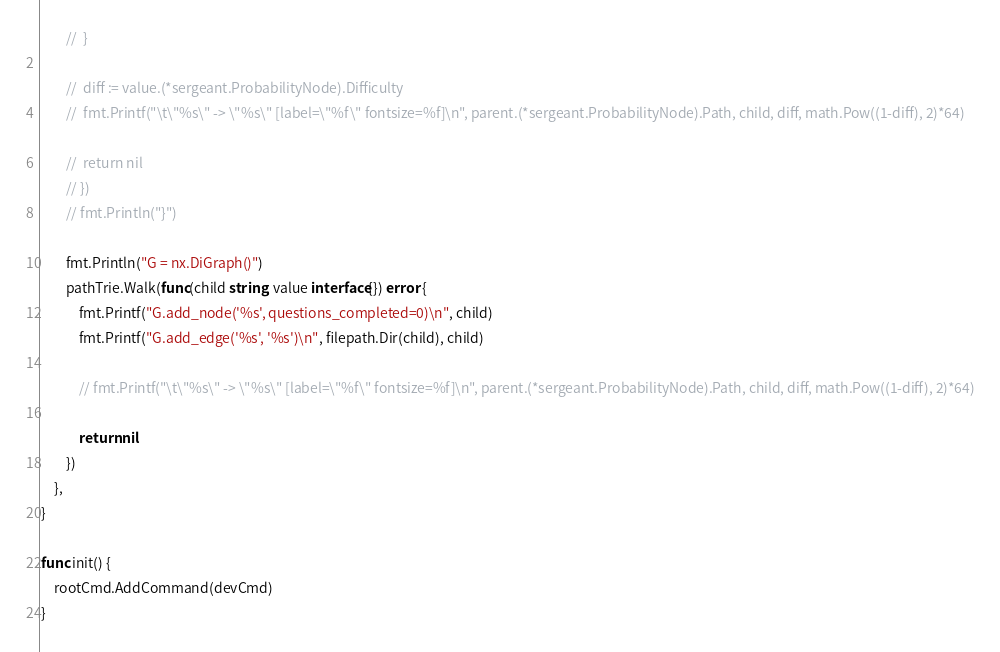Convert code to text. <code><loc_0><loc_0><loc_500><loc_500><_Go_>		// 	}

		// 	diff := value.(*sergeant.ProbabilityNode).Difficulty
		// 	fmt.Printf("\t\"%s\" -> \"%s\" [label=\"%f\" fontsize=%f]\n", parent.(*sergeant.ProbabilityNode).Path, child, diff, math.Pow((1-diff), 2)*64)

		// 	return nil
		// })
		// fmt.Println("}")

		fmt.Println("G = nx.DiGraph()")
		pathTrie.Walk(func(child string, value interface{}) error {
			fmt.Printf("G.add_node('%s', questions_completed=0)\n", child)
			fmt.Printf("G.add_edge('%s', '%s')\n", filepath.Dir(child), child)

			// fmt.Printf("\t\"%s\" -> \"%s\" [label=\"%f\" fontsize=%f]\n", parent.(*sergeant.ProbabilityNode).Path, child, diff, math.Pow((1-diff), 2)*64)

			return nil
		})
	},
}

func init() {
	rootCmd.AddCommand(devCmd)
}
</code> 